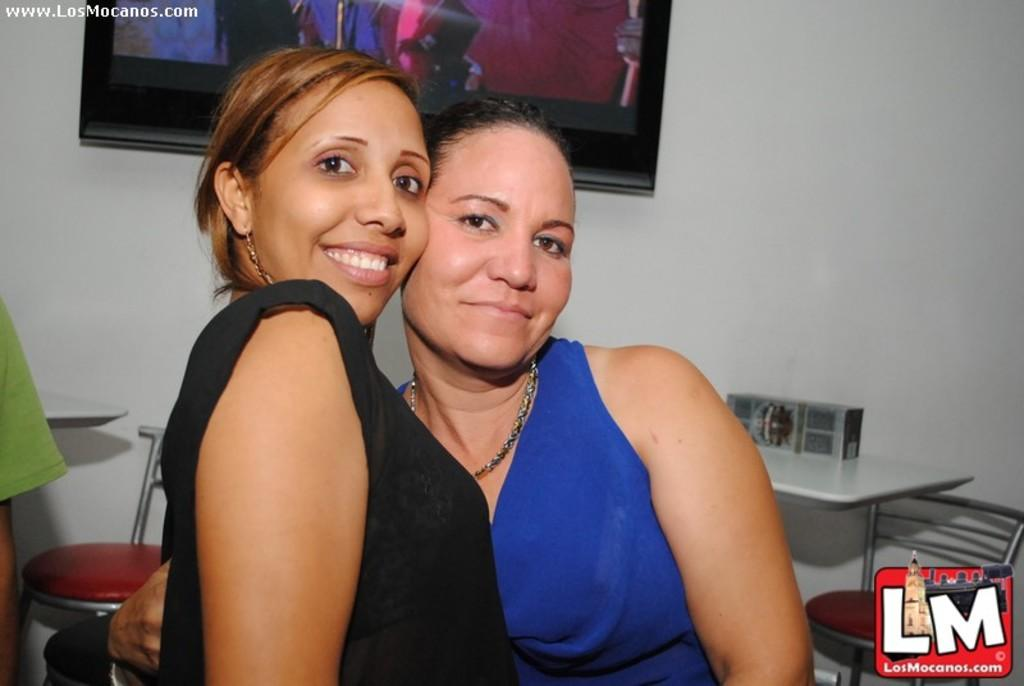How many people are present in the image? There are two persons in the image. What is the facial expression of the persons in the image? The two persons are smiling. What can be seen in the background of the image? There is a wall, a photo frame, a table, and chairs in the background of the image. Are there any other people visible in the background? Yes, there are two additional persons in the background of the image. What type of jellyfish can be seen on the table in the image? There is no jellyfish present in the image, and no jellyfish can be seen on the table. What type of plantation is visible in the background of the image? There is no plantation visible in the background of the image. 